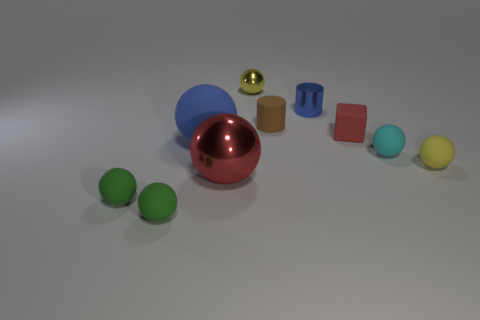Subtract all big blue balls. How many balls are left? 6 Subtract all gray cylinders. How many green balls are left? 2 Subtract 1 balls. How many balls are left? 6 Subtract all yellow spheres. How many spheres are left? 5 Subtract all yellow spheres. Subtract all brown blocks. How many spheres are left? 5 Subtract all cylinders. How many objects are left? 8 Subtract 0 cyan cylinders. How many objects are left? 10 Subtract all tiny balls. Subtract all tiny yellow rubber balls. How many objects are left? 4 Add 3 big spheres. How many big spheres are left? 5 Add 9 small yellow rubber cylinders. How many small yellow rubber cylinders exist? 9 